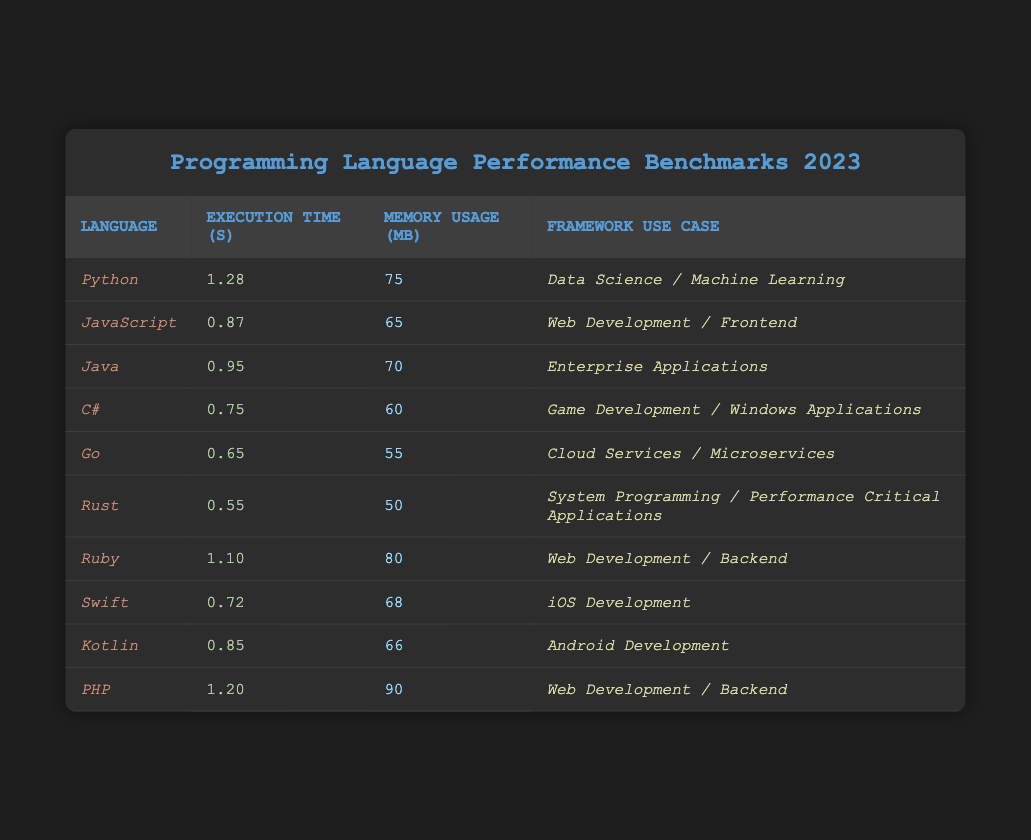What's the execution time of Rust? In the table, locate the row for Rust, where the execution time is listed as 0.55 seconds.
Answer: 0.55 seconds Which programming language has the highest memory usage? Scanning the memory usage column, PHP has the highest memory usage at 90 MB.
Answer: PHP What is the execution time difference between Go and C#? Go has an execution time of 0.65 seconds and C# has 0.75 seconds. The difference is calculated as 0.75 - 0.65 = 0.10 seconds.
Answer: 0.10 seconds Is Swift faster than JavaScript? Swift's execution time is 0.72 seconds and JavaScript's is 0.87 seconds. Since 0.72 is less than 0.87, Swift is indeed faster.
Answer: Yes What is the average execution time of all listed programming languages? First, sum all execution times: 1.28 + 0.87 + 0.95 + 0.75 + 0.65 + 0.55 + 1.10 + 0.72 + 0.85 + 1.20 = 8.72. There are 10 languages, so the average is 8.72 / 10 = 0.872 seconds.
Answer: 0.872 seconds Which programming language uses the least amount of memory? Checking the memory usage column, Rust has the lowest at 50 MB.
Answer: Rust How much faster is Go compared to Python? Go's execution time is 0.65 seconds and Python's is 1.28 seconds. The difference is 1.28 - 0.65 = 0.63 seconds, indicating Go is faster by this amount.
Answer: 0.63 seconds Does Ruby have a higher execution time than Java? Ruby has an execution time of 1.10 seconds while Java has 0.95 seconds. Since 1.10 is greater than 0.95, the statement is true.
Answer: Yes What programming language has the best performance based on execution time? By examining the execution times, Rust has the best performance with 0.55 seconds.
Answer: Rust What is the total memory usage of all programming languages combined? Summing the memory values: 75 + 65 + 70 + 60 + 55 + 50 + 80 + 68 + 66 + 90 =  825 MB.
Answer: 825 MB 